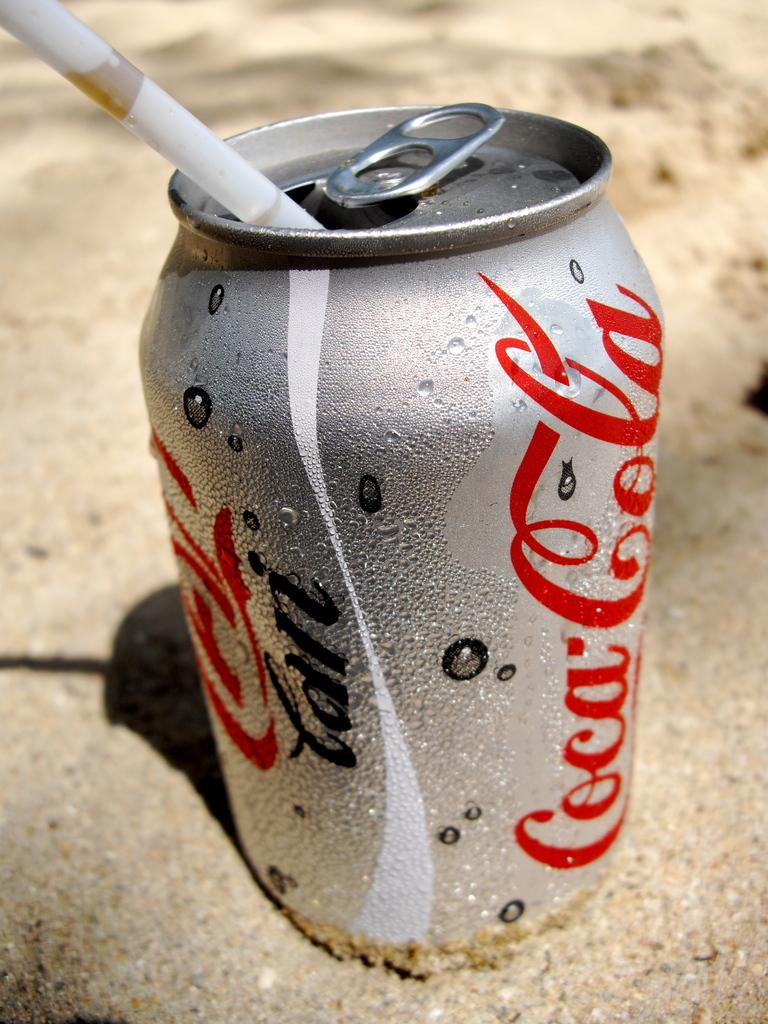<image>
Provide a brief description of the given image. A coca cola can with a straw in it is sitting on the sand. 